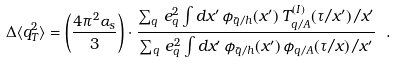<formula> <loc_0><loc_0><loc_500><loc_500>\Delta \langle q _ { T } ^ { 2 } \rangle = \left ( \frac { 4 \pi ^ { 2 } \alpha _ { s } } { 3 } \right ) \cdot \frac { \sum _ { q } \, e _ { q } ^ { 2 } \int d x ^ { \prime } \, \phi _ { \bar { q } / h } ( x ^ { \prime } ) \, T _ { q / A } ^ { ( I ) } ( \tau / x ^ { \prime } ) / x ^ { \prime } } { \sum _ { q } \, e _ { q } ^ { 2 } \int d x ^ { \prime } \, \phi _ { \bar { q } / h } ( x ^ { \prime } ) \, \phi _ { q / A } ( \tau / x ) / x ^ { \prime } } \ .</formula> 